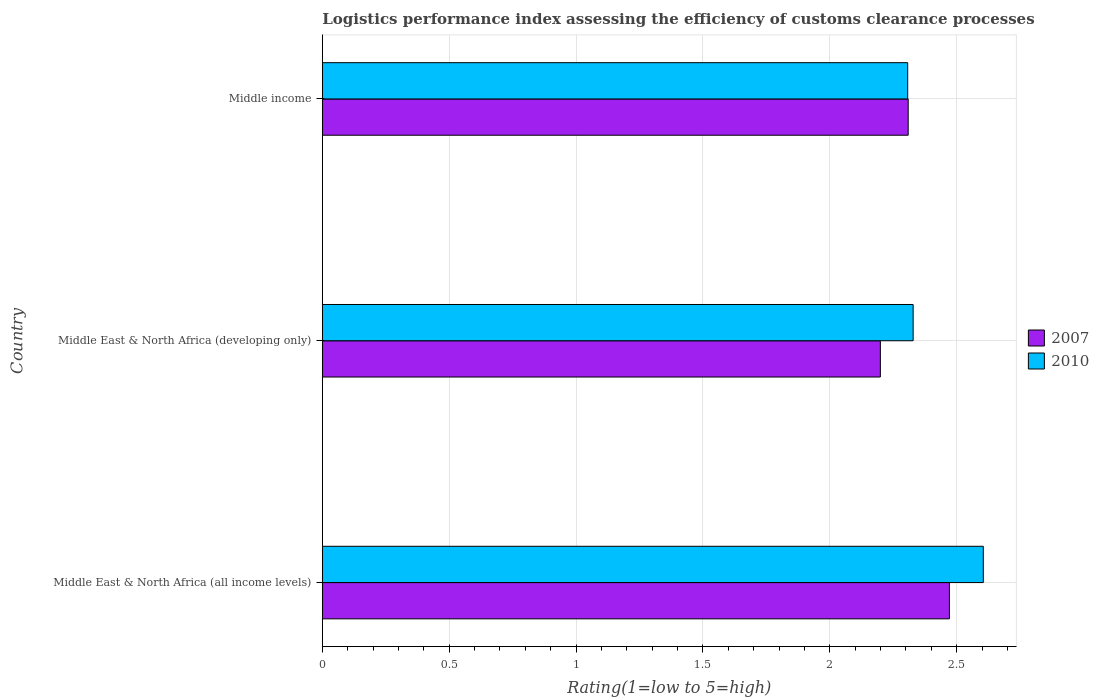How many different coloured bars are there?
Provide a succinct answer. 2. How many groups of bars are there?
Make the answer very short. 3. Are the number of bars per tick equal to the number of legend labels?
Your answer should be very brief. Yes. Are the number of bars on each tick of the Y-axis equal?
Make the answer very short. Yes. How many bars are there on the 1st tick from the top?
Keep it short and to the point. 2. How many bars are there on the 3rd tick from the bottom?
Your response must be concise. 2. What is the label of the 1st group of bars from the top?
Your response must be concise. Middle income. What is the Logistic performance index in 2010 in Middle East & North Africa (all income levels)?
Give a very brief answer. 2.6. Across all countries, what is the maximum Logistic performance index in 2007?
Ensure brevity in your answer.  2.47. Across all countries, what is the minimum Logistic performance index in 2007?
Your answer should be compact. 2.2. In which country was the Logistic performance index in 2010 maximum?
Your answer should be very brief. Middle East & North Africa (all income levels). In which country was the Logistic performance index in 2010 minimum?
Offer a very short reply. Middle income. What is the total Logistic performance index in 2010 in the graph?
Your response must be concise. 7.24. What is the difference between the Logistic performance index in 2010 in Middle East & North Africa (developing only) and that in Middle income?
Provide a short and direct response. 0.02. What is the difference between the Logistic performance index in 2007 in Middle East & North Africa (all income levels) and the Logistic performance index in 2010 in Middle East & North Africa (developing only)?
Give a very brief answer. 0.14. What is the average Logistic performance index in 2010 per country?
Ensure brevity in your answer.  2.41. What is the difference between the Logistic performance index in 2010 and Logistic performance index in 2007 in Middle East & North Africa (all income levels)?
Ensure brevity in your answer.  0.13. In how many countries, is the Logistic performance index in 2010 greater than 0.6 ?
Offer a terse response. 3. What is the ratio of the Logistic performance index in 2010 in Middle East & North Africa (all income levels) to that in Middle income?
Offer a terse response. 1.13. Is the Logistic performance index in 2007 in Middle East & North Africa (all income levels) less than that in Middle East & North Africa (developing only)?
Offer a terse response. No. What is the difference between the highest and the second highest Logistic performance index in 2007?
Keep it short and to the point. 0.16. What is the difference between the highest and the lowest Logistic performance index in 2010?
Your response must be concise. 0.3. Is the sum of the Logistic performance index in 2010 in Middle East & North Africa (all income levels) and Middle income greater than the maximum Logistic performance index in 2007 across all countries?
Keep it short and to the point. Yes. What does the 1st bar from the bottom in Middle income represents?
Ensure brevity in your answer.  2007. How many bars are there?
Ensure brevity in your answer.  6. Are the values on the major ticks of X-axis written in scientific E-notation?
Make the answer very short. No. Does the graph contain any zero values?
Make the answer very short. No. How many legend labels are there?
Offer a very short reply. 2. What is the title of the graph?
Keep it short and to the point. Logistics performance index assessing the efficiency of customs clearance processes. What is the label or title of the X-axis?
Offer a terse response. Rating(1=low to 5=high). What is the label or title of the Y-axis?
Keep it short and to the point. Country. What is the Rating(1=low to 5=high) of 2007 in Middle East & North Africa (all income levels)?
Your answer should be very brief. 2.47. What is the Rating(1=low to 5=high) of 2010 in Middle East & North Africa (all income levels)?
Your answer should be very brief. 2.6. What is the Rating(1=low to 5=high) in 2007 in Middle East & North Africa (developing only)?
Your answer should be compact. 2.2. What is the Rating(1=low to 5=high) in 2010 in Middle East & North Africa (developing only)?
Your response must be concise. 2.33. What is the Rating(1=low to 5=high) in 2007 in Middle income?
Offer a terse response. 2.31. What is the Rating(1=low to 5=high) of 2010 in Middle income?
Make the answer very short. 2.31. Across all countries, what is the maximum Rating(1=low to 5=high) of 2007?
Provide a short and direct response. 2.47. Across all countries, what is the maximum Rating(1=low to 5=high) in 2010?
Your answer should be compact. 2.6. Across all countries, what is the minimum Rating(1=low to 5=high) of 2007?
Offer a very short reply. 2.2. Across all countries, what is the minimum Rating(1=low to 5=high) of 2010?
Provide a short and direct response. 2.31. What is the total Rating(1=low to 5=high) in 2007 in the graph?
Your response must be concise. 6.98. What is the total Rating(1=low to 5=high) in 2010 in the graph?
Your answer should be very brief. 7.24. What is the difference between the Rating(1=low to 5=high) in 2007 in Middle East & North Africa (all income levels) and that in Middle East & North Africa (developing only)?
Offer a terse response. 0.27. What is the difference between the Rating(1=low to 5=high) in 2010 in Middle East & North Africa (all income levels) and that in Middle East & North Africa (developing only)?
Provide a short and direct response. 0.28. What is the difference between the Rating(1=low to 5=high) in 2007 in Middle East & North Africa (all income levels) and that in Middle income?
Provide a short and direct response. 0.16. What is the difference between the Rating(1=low to 5=high) in 2010 in Middle East & North Africa (all income levels) and that in Middle income?
Provide a succinct answer. 0.3. What is the difference between the Rating(1=low to 5=high) of 2007 in Middle East & North Africa (developing only) and that in Middle income?
Your response must be concise. -0.11. What is the difference between the Rating(1=low to 5=high) in 2010 in Middle East & North Africa (developing only) and that in Middle income?
Provide a succinct answer. 0.02. What is the difference between the Rating(1=low to 5=high) of 2007 in Middle East & North Africa (all income levels) and the Rating(1=low to 5=high) of 2010 in Middle East & North Africa (developing only)?
Give a very brief answer. 0.14. What is the difference between the Rating(1=low to 5=high) of 2007 in Middle East & North Africa (all income levels) and the Rating(1=low to 5=high) of 2010 in Middle income?
Offer a very short reply. 0.16. What is the difference between the Rating(1=low to 5=high) of 2007 in Middle East & North Africa (developing only) and the Rating(1=low to 5=high) of 2010 in Middle income?
Offer a terse response. -0.11. What is the average Rating(1=low to 5=high) in 2007 per country?
Ensure brevity in your answer.  2.33. What is the average Rating(1=low to 5=high) of 2010 per country?
Your response must be concise. 2.41. What is the difference between the Rating(1=low to 5=high) of 2007 and Rating(1=low to 5=high) of 2010 in Middle East & North Africa (all income levels)?
Give a very brief answer. -0.13. What is the difference between the Rating(1=low to 5=high) in 2007 and Rating(1=low to 5=high) in 2010 in Middle East & North Africa (developing only)?
Provide a short and direct response. -0.13. What is the difference between the Rating(1=low to 5=high) in 2007 and Rating(1=low to 5=high) in 2010 in Middle income?
Offer a terse response. 0. What is the ratio of the Rating(1=low to 5=high) in 2007 in Middle East & North Africa (all income levels) to that in Middle East & North Africa (developing only)?
Provide a succinct answer. 1.12. What is the ratio of the Rating(1=low to 5=high) in 2010 in Middle East & North Africa (all income levels) to that in Middle East & North Africa (developing only)?
Your answer should be compact. 1.12. What is the ratio of the Rating(1=low to 5=high) of 2007 in Middle East & North Africa (all income levels) to that in Middle income?
Make the answer very short. 1.07. What is the ratio of the Rating(1=low to 5=high) of 2010 in Middle East & North Africa (all income levels) to that in Middle income?
Keep it short and to the point. 1.13. What is the ratio of the Rating(1=low to 5=high) of 2007 in Middle East & North Africa (developing only) to that in Middle income?
Make the answer very short. 0.95. What is the ratio of the Rating(1=low to 5=high) in 2010 in Middle East & North Africa (developing only) to that in Middle income?
Make the answer very short. 1.01. What is the difference between the highest and the second highest Rating(1=low to 5=high) in 2007?
Offer a very short reply. 0.16. What is the difference between the highest and the second highest Rating(1=low to 5=high) of 2010?
Your answer should be compact. 0.28. What is the difference between the highest and the lowest Rating(1=low to 5=high) in 2007?
Your response must be concise. 0.27. What is the difference between the highest and the lowest Rating(1=low to 5=high) in 2010?
Ensure brevity in your answer.  0.3. 